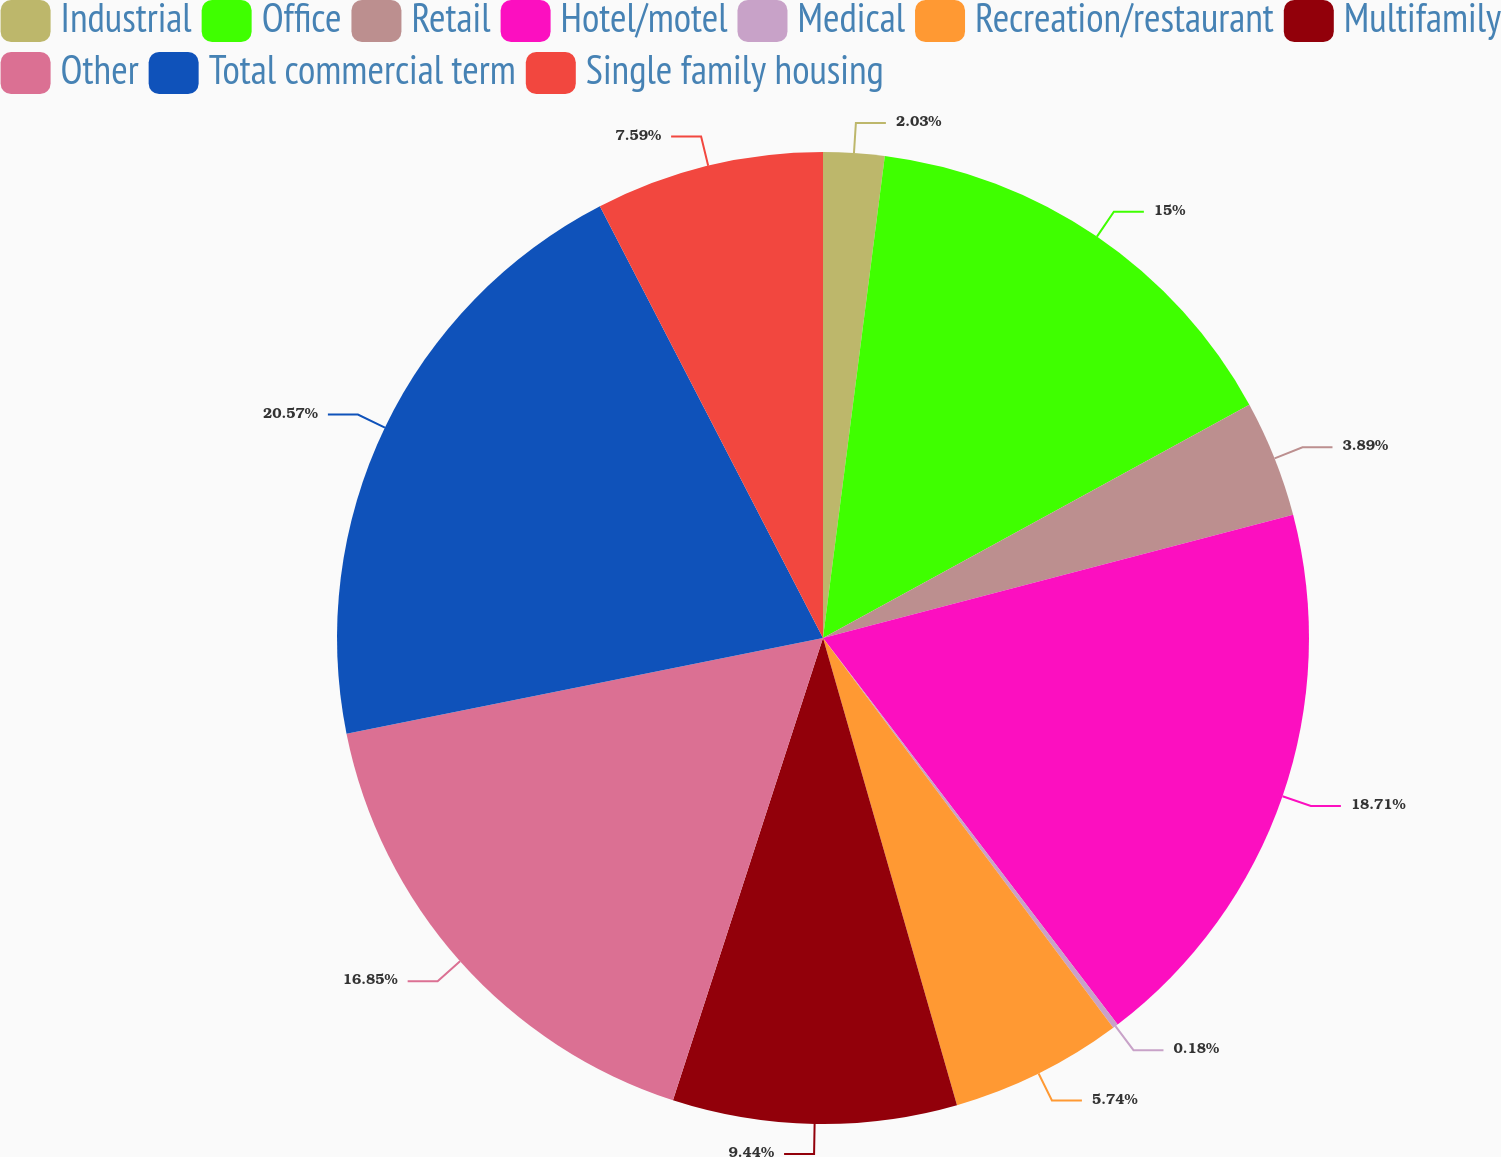Convert chart. <chart><loc_0><loc_0><loc_500><loc_500><pie_chart><fcel>Industrial<fcel>Office<fcel>Retail<fcel>Hotel/motel<fcel>Medical<fcel>Recreation/restaurant<fcel>Multifamily<fcel>Other<fcel>Total commercial term<fcel>Single family housing<nl><fcel>2.03%<fcel>15.0%<fcel>3.89%<fcel>18.71%<fcel>0.18%<fcel>5.74%<fcel>9.44%<fcel>16.85%<fcel>20.56%<fcel>7.59%<nl></chart> 